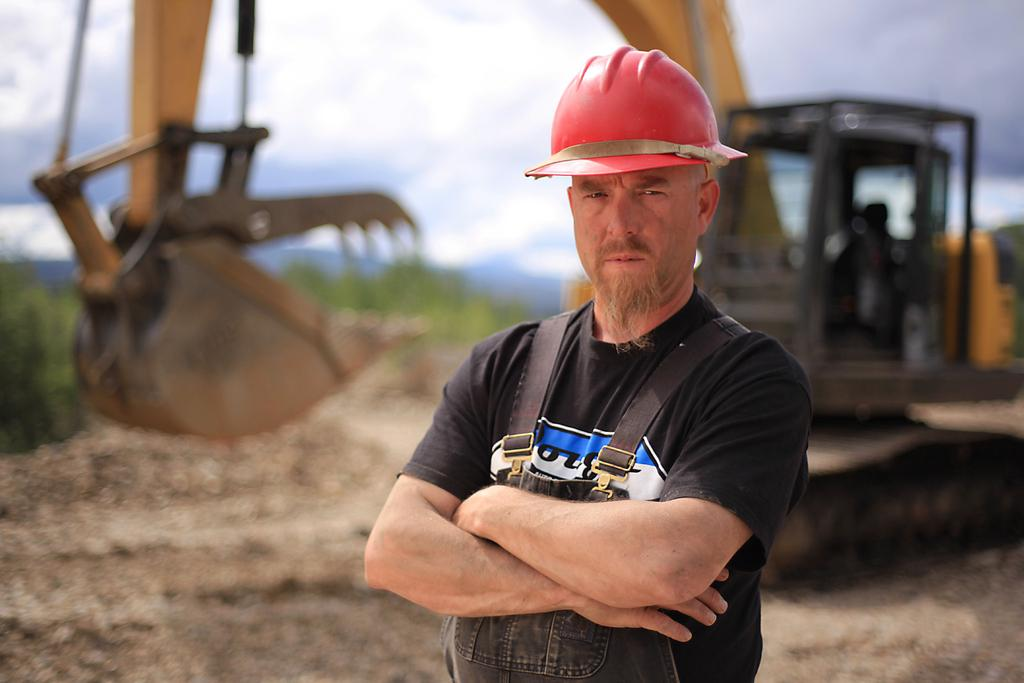What is the main subject of the image? There is a person standing in the image. What object can be seen on the ground in the image? There is a crane on the ground in the image. What type of natural elements are visible in the image? There are trees visible in the image. What part of the environment is visible in the image? The sky is visible in the image. How many cobwebs can be seen on the person in the image? There are no cobwebs visible on the person in the image. What advice might the person's uncle give them in the image? There is no indication of the person's uncle being present in the image, so it's not possible to determine what advice they might give. 